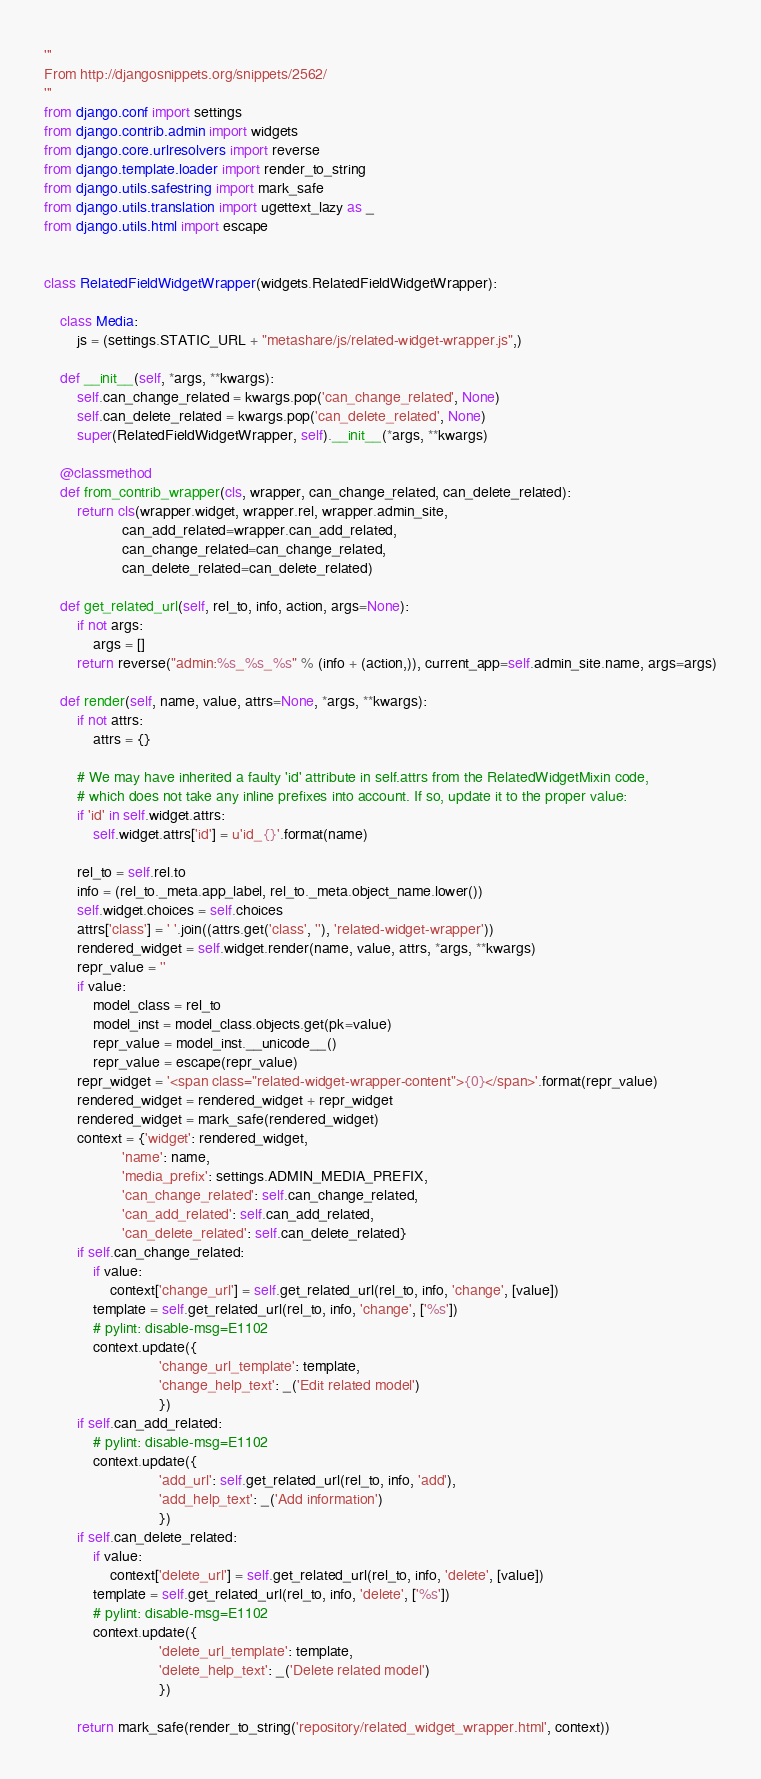<code> <loc_0><loc_0><loc_500><loc_500><_Python_>'''
From http://djangosnippets.org/snippets/2562/
'''
from django.conf import settings
from django.contrib.admin import widgets
from django.core.urlresolvers import reverse
from django.template.loader import render_to_string
from django.utils.safestring import mark_safe
from django.utils.translation import ugettext_lazy as _
from django.utils.html import escape


class RelatedFieldWidgetWrapper(widgets.RelatedFieldWidgetWrapper):
    
    class Media:
        js = (settings.STATIC_URL + "metashare/js/related-widget-wrapper.js",)
    
    def __init__(self, *args, **kwargs):
        self.can_change_related = kwargs.pop('can_change_related', None)
        self.can_delete_related = kwargs.pop('can_delete_related', None)
        super(RelatedFieldWidgetWrapper, self).__init__(*args, **kwargs)
    
    @classmethod
    def from_contrib_wrapper(cls, wrapper, can_change_related, can_delete_related):
        return cls(wrapper.widget, wrapper.rel, wrapper.admin_site,
                   can_add_related=wrapper.can_add_related,
                   can_change_related=can_change_related,
                   can_delete_related=can_delete_related)
    
    def get_related_url(self, rel_to, info, action, args=None):
        if not args:
            args = []
        return reverse("admin:%s_%s_%s" % (info + (action,)), current_app=self.admin_site.name, args=args)
    
    def render(self, name, value, attrs=None, *args, **kwargs):
        if not attrs:
            attrs = {}
        
        # We may have inherited a faulty 'id' attribute in self.attrs from the RelatedWidgetMixin code,
        # which does not take any inline prefixes into account. If so, update it to the proper value:
        if 'id' in self.widget.attrs:
            self.widget.attrs['id'] = u'id_{}'.format(name)
        
        rel_to = self.rel.to
        info = (rel_to._meta.app_label, rel_to._meta.object_name.lower())
        self.widget.choices = self.choices
        attrs['class'] = ' '.join((attrs.get('class', ''), 'related-widget-wrapper'))
        rendered_widget = self.widget.render(name, value, attrs, *args, **kwargs)
        repr_value = ''
        if value:
            model_class = rel_to
            model_inst = model_class.objects.get(pk=value)
            repr_value = model_inst.__unicode__()
            repr_value = escape(repr_value)
        repr_widget = '<span class="related-widget-wrapper-content">{0}</span>'.format(repr_value)
        rendered_widget = rendered_widget + repr_widget
        rendered_widget = mark_safe(rendered_widget)
        context = {'widget': rendered_widget,
                   'name': name,
                   'media_prefix': settings.ADMIN_MEDIA_PREFIX,
                   'can_change_related': self.can_change_related,
                   'can_add_related': self.can_add_related,
                   'can_delete_related': self.can_delete_related}
        if self.can_change_related:
            if value:
                context['change_url'] = self.get_related_url(rel_to, info, 'change', [value])
            template = self.get_related_url(rel_to, info, 'change', ['%s'])
            # pylint: disable-msg=E1102
            context.update({
                            'change_url_template': template,
                            'change_help_text': _('Edit related model')
                            })
        if self.can_add_related:
            # pylint: disable-msg=E1102
            context.update({
                            'add_url': self.get_related_url(rel_to, info, 'add'),
                            'add_help_text': _('Add information')
                            })
        if self.can_delete_related:
            if value:
                context['delete_url'] = self.get_related_url(rel_to, info, 'delete', [value])
            template = self.get_related_url(rel_to, info, 'delete', ['%s'])
            # pylint: disable-msg=E1102
            context.update({
                            'delete_url_template': template,
                            'delete_help_text': _('Delete related model')
                            })
        
        return mark_safe(render_to_string('repository/related_widget_wrapper.html', context))
</code> 